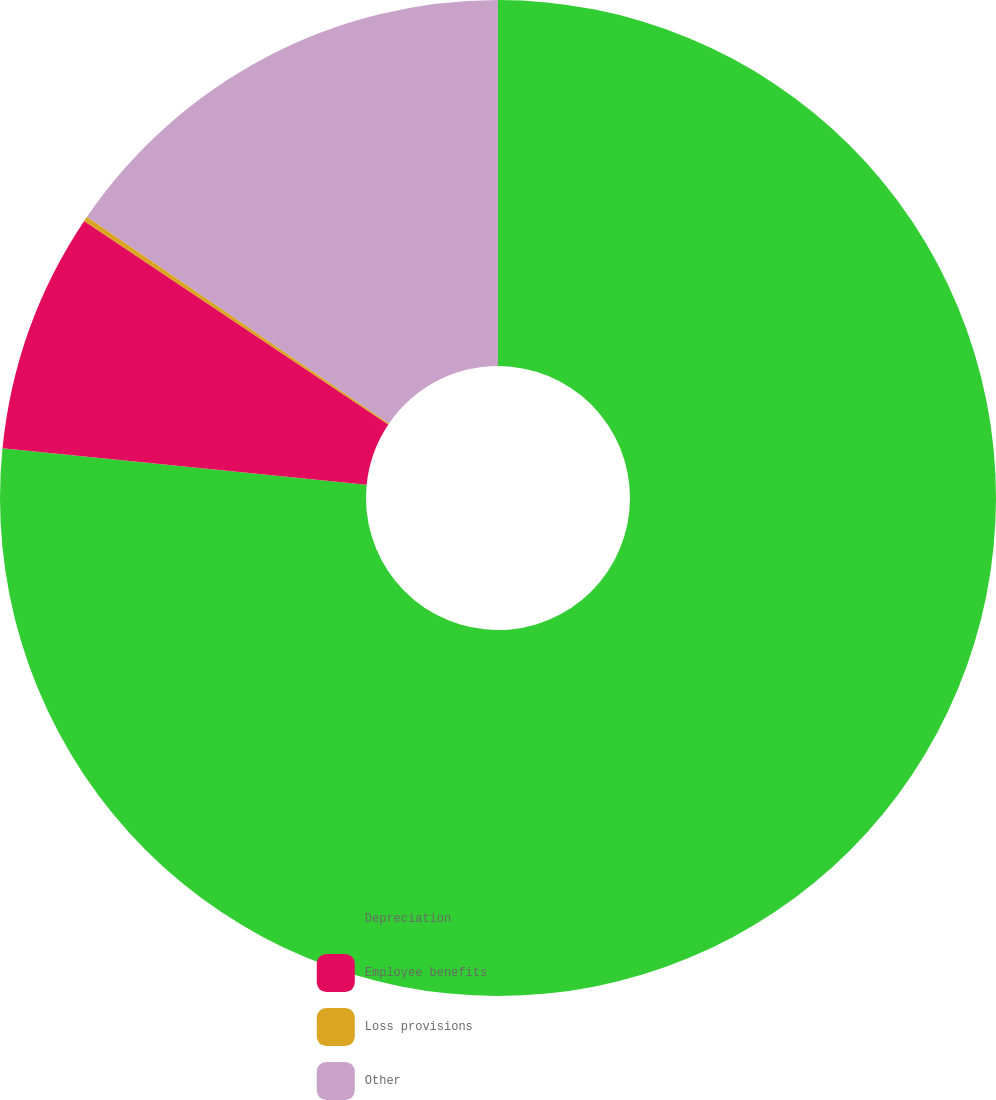Convert chart to OTSL. <chart><loc_0><loc_0><loc_500><loc_500><pie_chart><fcel>Depreciation<fcel>Employee benefits<fcel>Loss provisions<fcel>Other<nl><fcel>76.59%<fcel>7.8%<fcel>0.16%<fcel>15.45%<nl></chart> 